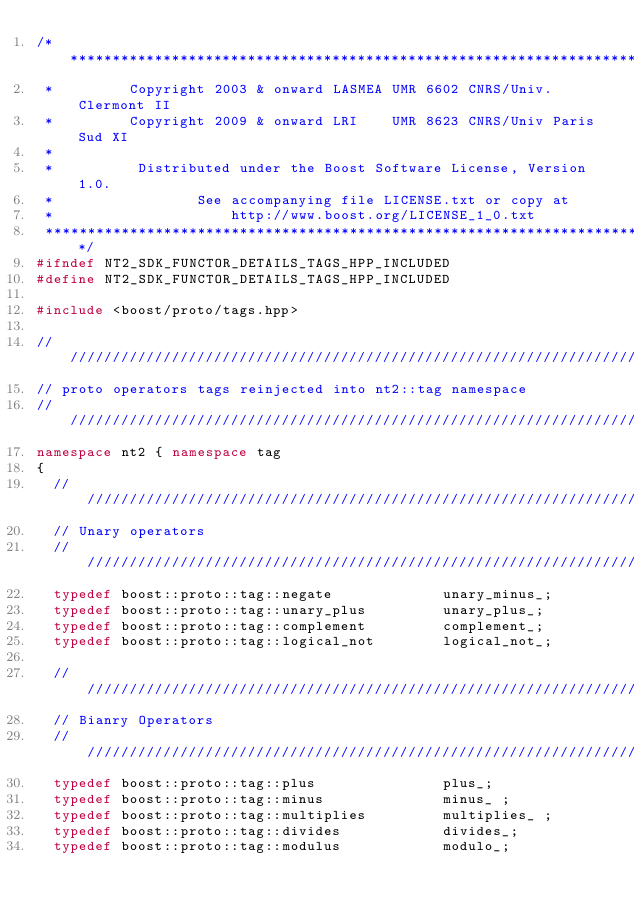Convert code to text. <code><loc_0><loc_0><loc_500><loc_500><_C++_>/*******************************************************************************
 *         Copyright 2003 & onward LASMEA UMR 6602 CNRS/Univ. Clermont II
 *         Copyright 2009 & onward LRI    UMR 8623 CNRS/Univ Paris Sud XI
 *
 *          Distributed under the Boost Software License, Version 1.0.
 *                 See accompanying file LICENSE.txt or copy at
 *                     http://www.boost.org/LICENSE_1_0.txt
 ******************************************************************************/
#ifndef NT2_SDK_FUNCTOR_DETAILS_TAGS_HPP_INCLUDED
#define NT2_SDK_FUNCTOR_DETAILS_TAGS_HPP_INCLUDED

#include <boost/proto/tags.hpp>

////////////////////////////////////////////////////////////////////////////////
// proto operators tags reinjected into nt2::tag namespace
////////////////////////////////////////////////////////////////////////////////
namespace nt2 { namespace tag
{
  //////////////////////////////////////////////////////////////////////////////
  // Unary operators
  //////////////////////////////////////////////////////////////////////////////
  typedef boost::proto::tag::negate             unary_minus_;
  typedef boost::proto::tag::unary_plus         unary_plus_;
  typedef boost::proto::tag::complement         complement_;
  typedef boost::proto::tag::logical_not        logical_not_;

  //////////////////////////////////////////////////////////////////////////////
  // Bianry Operators
  //////////////////////////////////////////////////////////////////////////////
  typedef boost::proto::tag::plus               plus_;
  typedef boost::proto::tag::minus              minus_ ;
  typedef boost::proto::tag::multiplies         multiplies_ ;
  typedef boost::proto::tag::divides            divides_;
  typedef boost::proto::tag::modulus            modulo_;</code> 